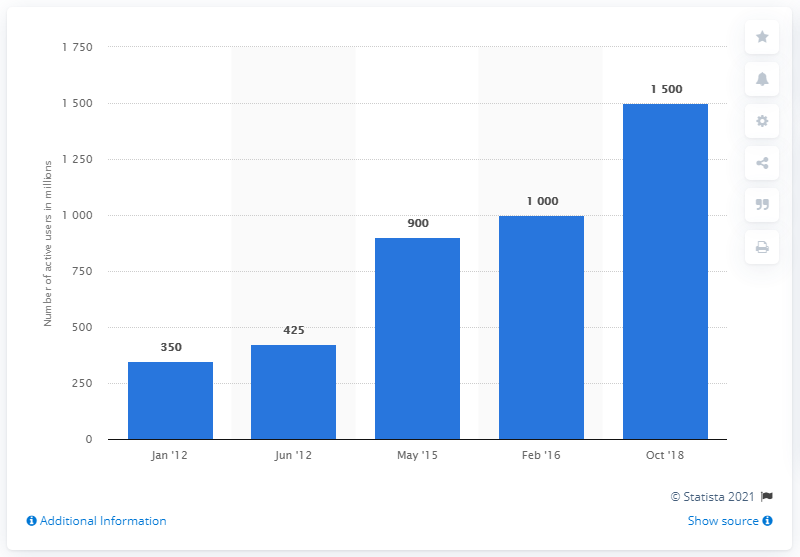Mention a couple of crucial points in this snapshot. Between January 2012 and October 2018, Google's e-mail service had an estimated number of active users worldwide, which was approximately 1500. 